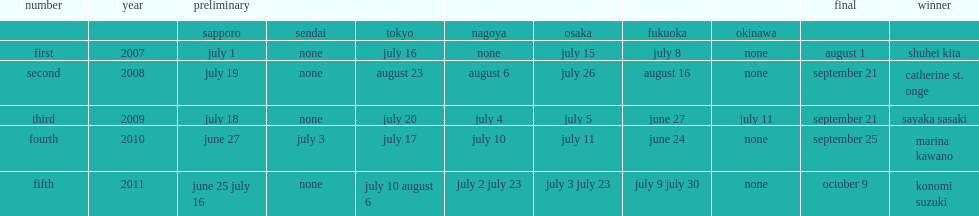When did the first animax anison grand prix hold? 2007.0. 